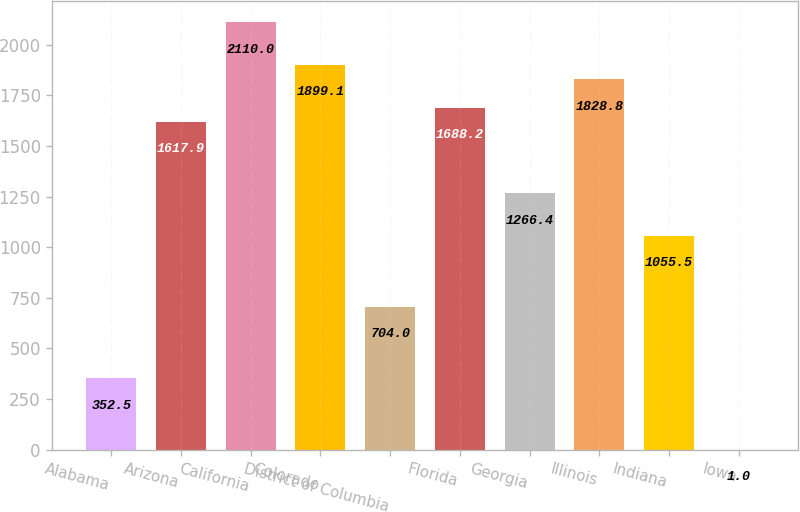Convert chart to OTSL. <chart><loc_0><loc_0><loc_500><loc_500><bar_chart><fcel>Alabama<fcel>Arizona<fcel>California<fcel>Colorado<fcel>District of Columbia<fcel>Florida<fcel>Georgia<fcel>Illinois<fcel>Indiana<fcel>Iowa<nl><fcel>352.5<fcel>1617.9<fcel>2110<fcel>1899.1<fcel>704<fcel>1688.2<fcel>1266.4<fcel>1828.8<fcel>1055.5<fcel>1<nl></chart> 